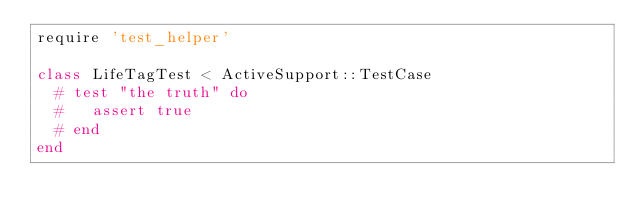Convert code to text. <code><loc_0><loc_0><loc_500><loc_500><_Ruby_>require 'test_helper'

class LifeTagTest < ActiveSupport::TestCase
  # test "the truth" do
  #   assert true
  # end
end
</code> 